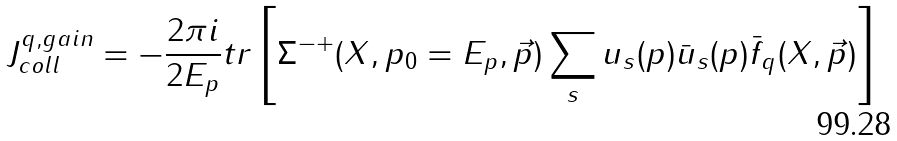<formula> <loc_0><loc_0><loc_500><loc_500>J _ { c o l l } ^ { q , g a i n } = - \frac { 2 \pi i } { 2 E _ { p } } t r \left [ \Sigma ^ { - + } ( X , p _ { 0 } = E _ { p } , \vec { p } ) \sum _ { s } u _ { s } ( p ) \bar { u } _ { s } ( p ) \bar { f } _ { q } ( X , \vec { p } ) \right ]</formula> 